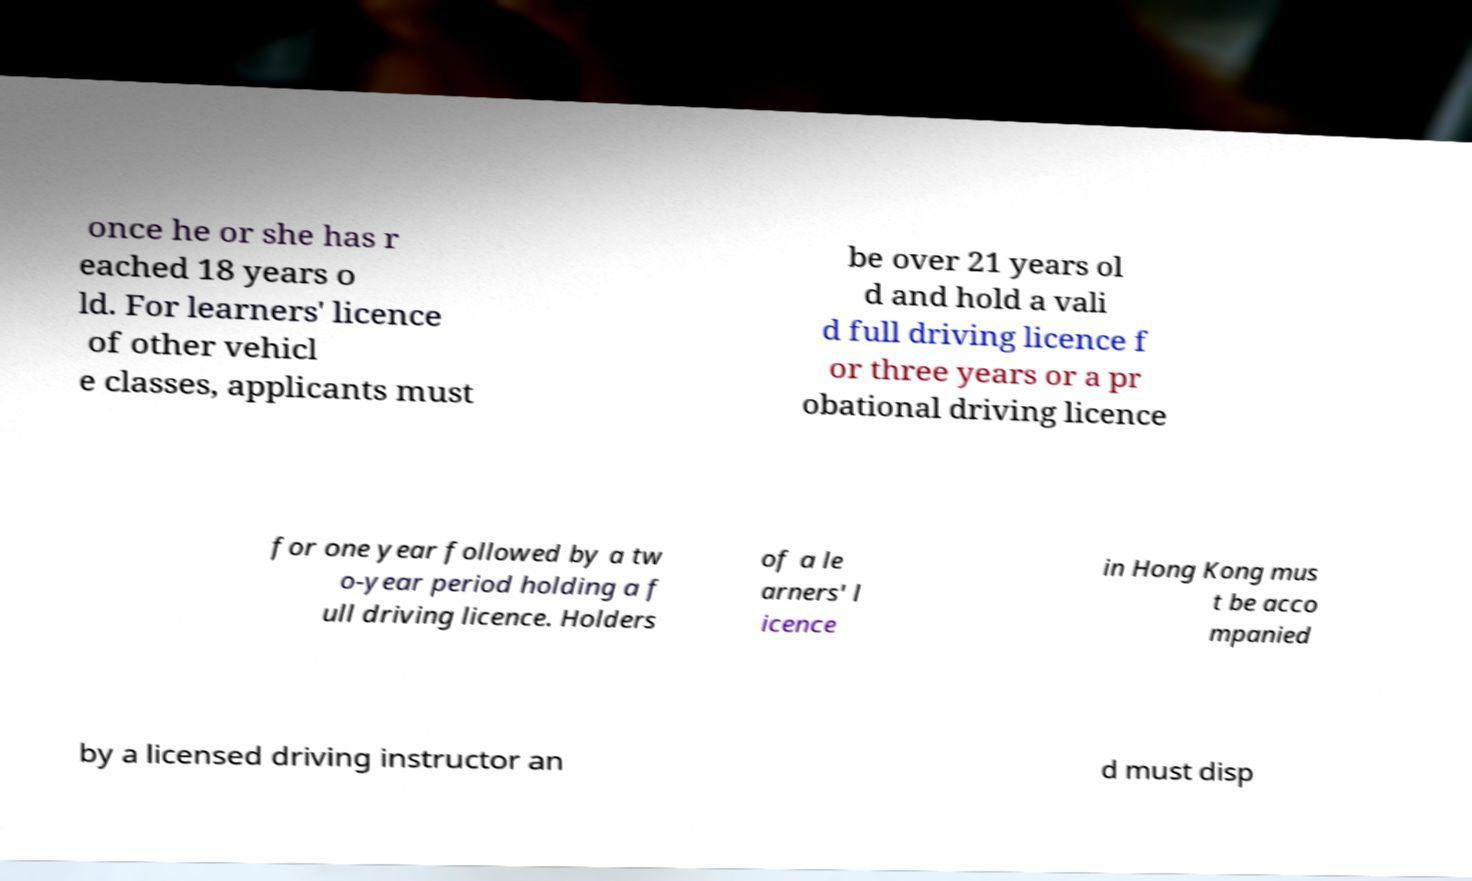Please identify and transcribe the text found in this image. once he or she has r eached 18 years o ld. For learners' licence of other vehicl e classes, applicants must be over 21 years ol d and hold a vali d full driving licence f or three years or a pr obational driving licence for one year followed by a tw o-year period holding a f ull driving licence. Holders of a le arners' l icence in Hong Kong mus t be acco mpanied by a licensed driving instructor an d must disp 